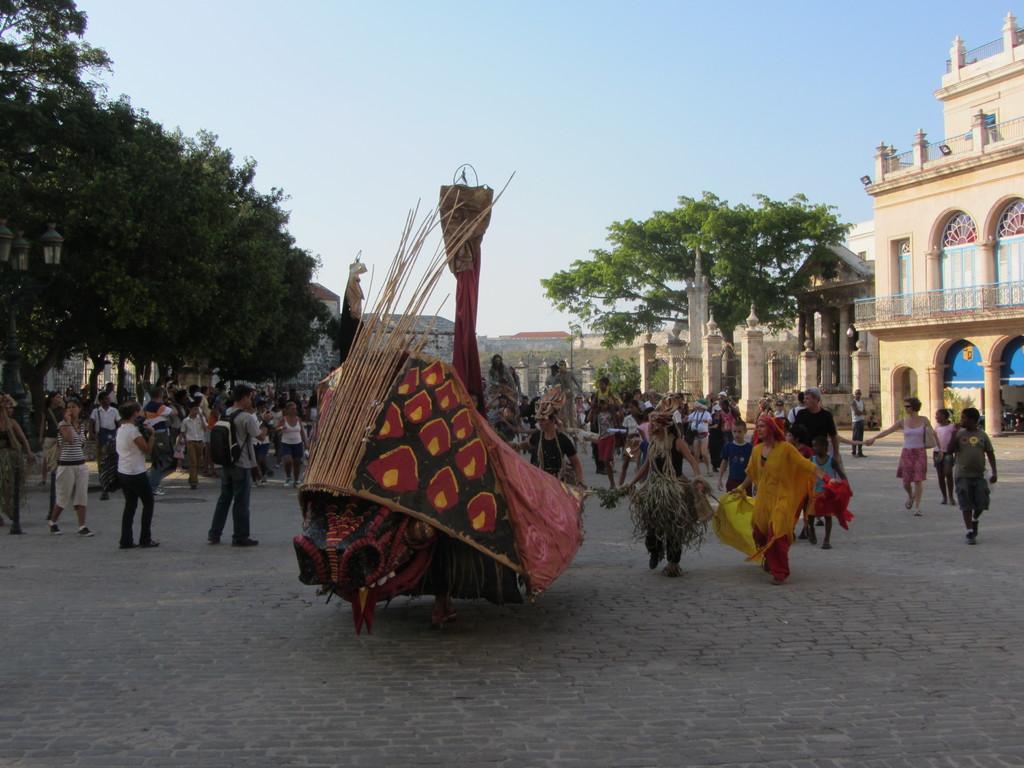How would you summarize this image in a sentence or two? In the picture we can see a path with some people are in different costumes and behind them, we can see some people are walking and some people are standing and looking at them and behind them we can see some trees, building and sky. 